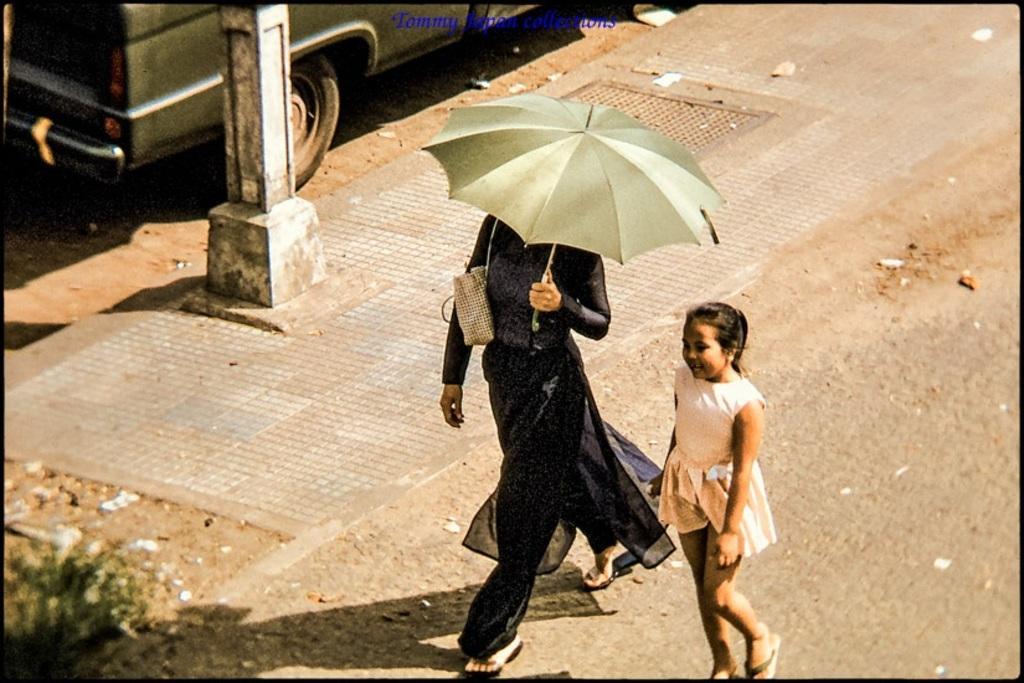Describe this image in one or two sentences. In this image we can see a person and a girl is walking on the road and the woman is holding an umbrella in the hand and carrying a bag on the shoulder. In the background we can see a vehicle on the ground, pole and metal door on a footpath. 